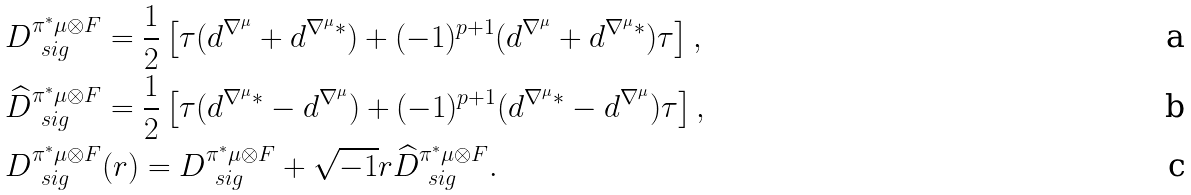Convert formula to latex. <formula><loc_0><loc_0><loc_500><loc_500>& D ^ { \pi ^ { * } \mu \otimes F } _ { \ s i g } = \frac { 1 } { 2 } \left [ \tau ( d ^ { \nabla ^ { \mu } } + d ^ { \nabla ^ { \mu } * } ) + ( - 1 ) ^ { p + 1 } ( d ^ { \nabla ^ { \mu } } + d ^ { \nabla ^ { \mu } * } ) \tau \right ] , \\ & \widehat { D } ^ { \pi ^ { * } \mu \otimes F } _ { \ s i g } = \frac { 1 } { 2 } \left [ \tau ( d ^ { \nabla ^ { \mu } * } - d ^ { \nabla ^ { \mu } } ) + ( - 1 ) ^ { p + 1 } ( d ^ { \nabla ^ { \mu } * } - d ^ { \nabla ^ { \mu } } ) \tau \right ] , \\ & D ^ { \pi ^ { * } \mu \otimes F } _ { \ s i g } ( r ) = D ^ { \pi ^ { * } \mu \otimes F } _ { \ s i g } + \sqrt { - 1 } r \widehat { D } ^ { \pi ^ { * } \mu \otimes F } _ { \ s i g } .</formula> 